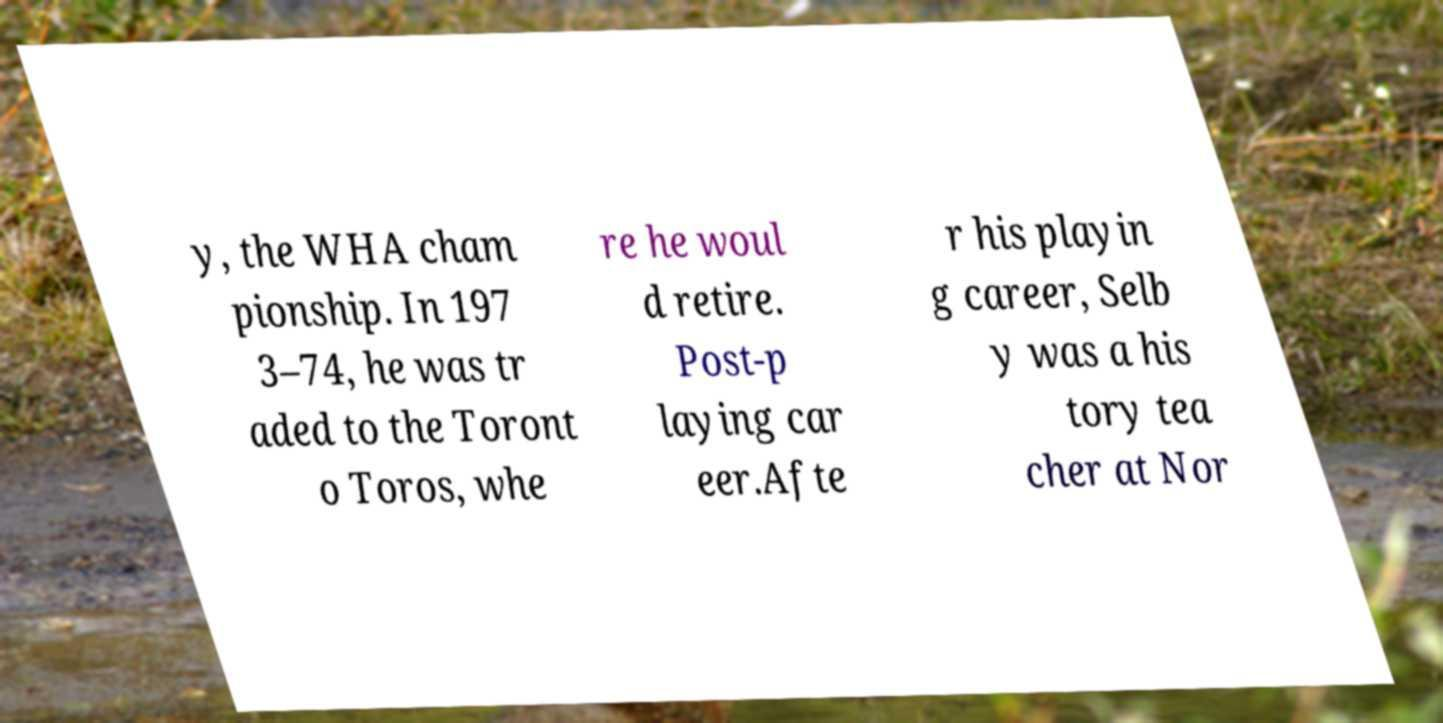What messages or text are displayed in this image? I need them in a readable, typed format. y, the WHA cham pionship. In 197 3–74, he was tr aded to the Toront o Toros, whe re he woul d retire. Post-p laying car eer.Afte r his playin g career, Selb y was a his tory tea cher at Nor 